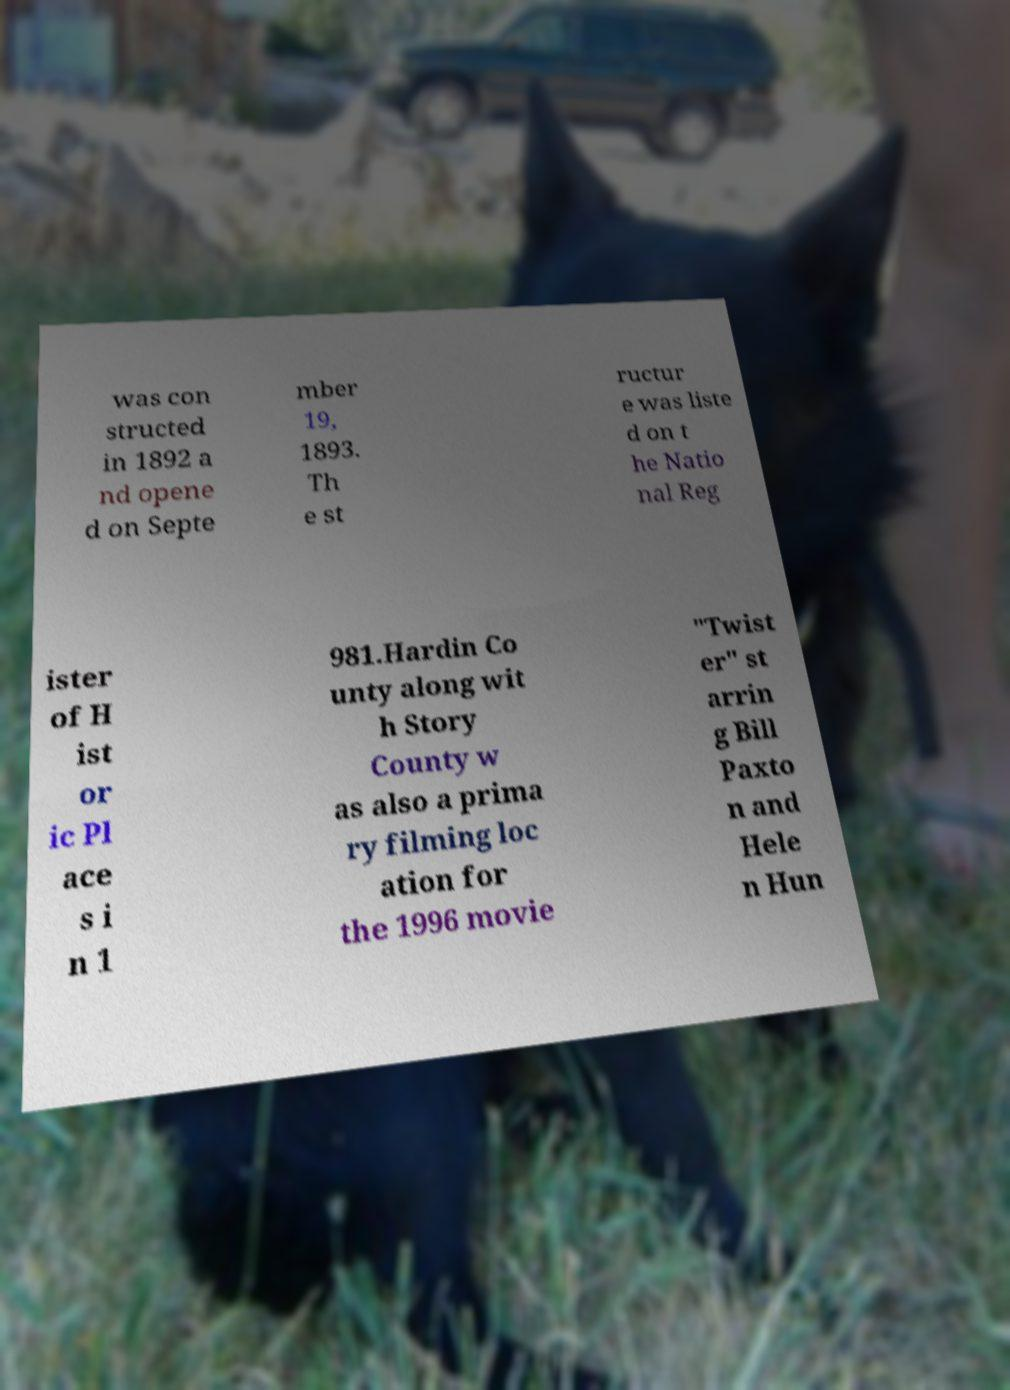Could you assist in decoding the text presented in this image and type it out clearly? was con structed in 1892 a nd opene d on Septe mber 19, 1893. Th e st ructur e was liste d on t he Natio nal Reg ister of H ist or ic Pl ace s i n 1 981.Hardin Co unty along wit h Story County w as also a prima ry filming loc ation for the 1996 movie "Twist er" st arrin g Bill Paxto n and Hele n Hun 